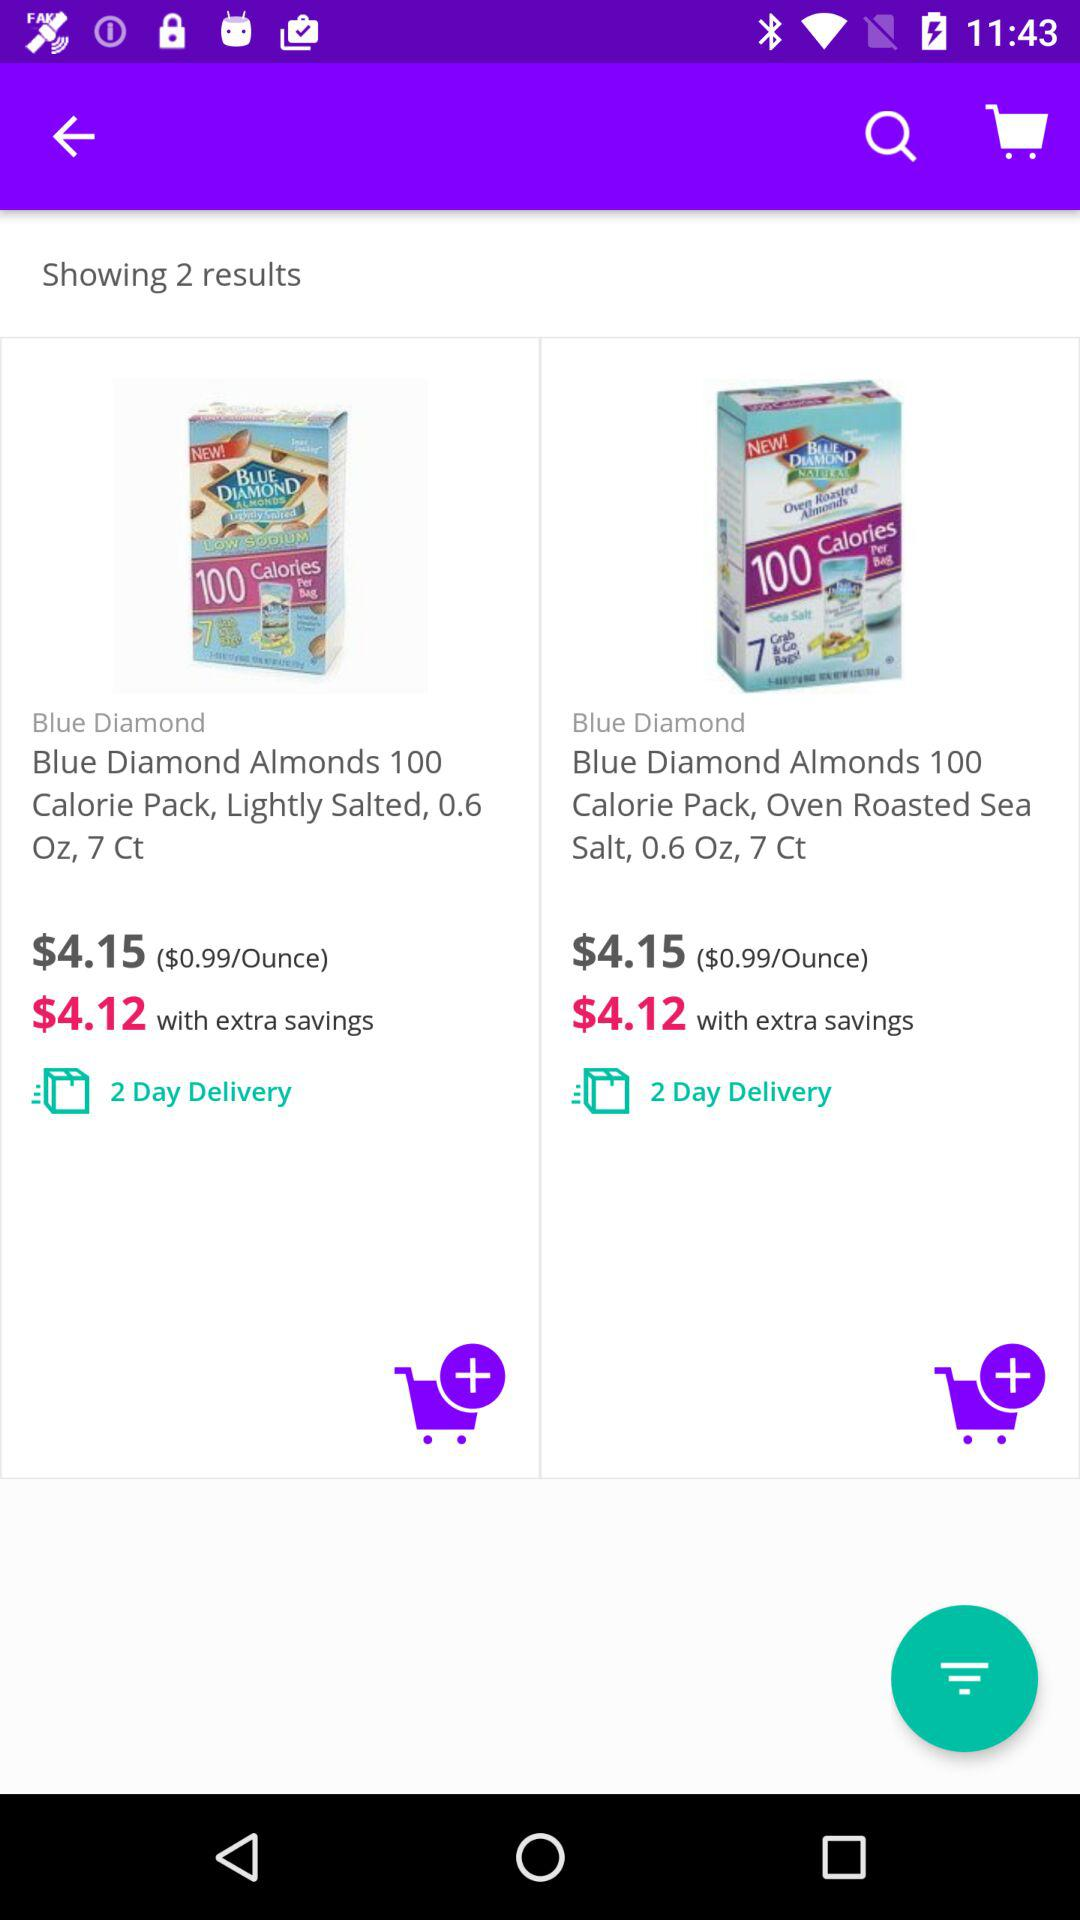How many items are available in the search results? There are precisely 2 items displayed in the search results, both of which appear to be from the same brand and are labeled as 100 Calorie Packs, one with lightly salted almonds and the other with oven roasted sea salt almonds. 